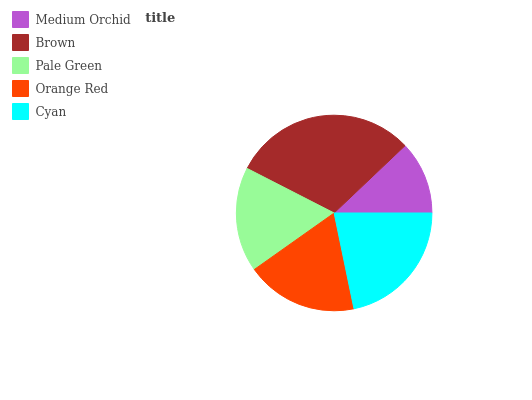Is Medium Orchid the minimum?
Answer yes or no. Yes. Is Brown the maximum?
Answer yes or no. Yes. Is Pale Green the minimum?
Answer yes or no. No. Is Pale Green the maximum?
Answer yes or no. No. Is Brown greater than Pale Green?
Answer yes or no. Yes. Is Pale Green less than Brown?
Answer yes or no. Yes. Is Pale Green greater than Brown?
Answer yes or no. No. Is Brown less than Pale Green?
Answer yes or no. No. Is Orange Red the high median?
Answer yes or no. Yes. Is Orange Red the low median?
Answer yes or no. Yes. Is Pale Green the high median?
Answer yes or no. No. Is Brown the low median?
Answer yes or no. No. 